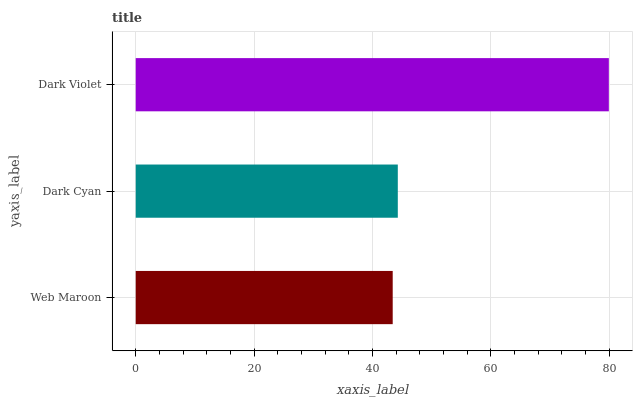Is Web Maroon the minimum?
Answer yes or no. Yes. Is Dark Violet the maximum?
Answer yes or no. Yes. Is Dark Cyan the minimum?
Answer yes or no. No. Is Dark Cyan the maximum?
Answer yes or no. No. Is Dark Cyan greater than Web Maroon?
Answer yes or no. Yes. Is Web Maroon less than Dark Cyan?
Answer yes or no. Yes. Is Web Maroon greater than Dark Cyan?
Answer yes or no. No. Is Dark Cyan less than Web Maroon?
Answer yes or no. No. Is Dark Cyan the high median?
Answer yes or no. Yes. Is Dark Cyan the low median?
Answer yes or no. Yes. Is Web Maroon the high median?
Answer yes or no. No. Is Dark Violet the low median?
Answer yes or no. No. 